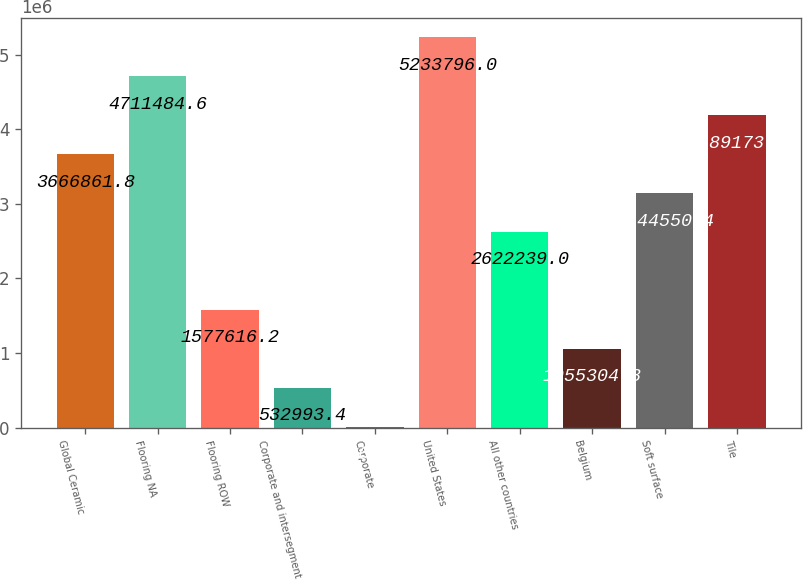Convert chart. <chart><loc_0><loc_0><loc_500><loc_500><bar_chart><fcel>Global Ceramic<fcel>Flooring NA<fcel>Flooring ROW<fcel>Corporate and intersegment<fcel>Corporate<fcel>United States<fcel>All other countries<fcel>Belgium<fcel>Soft surface<fcel>Tile<nl><fcel>3.66686e+06<fcel>4.71148e+06<fcel>1.57762e+06<fcel>532993<fcel>10682<fcel>5.2338e+06<fcel>2.62224e+06<fcel>1.0553e+06<fcel>3.14455e+06<fcel>4.18917e+06<nl></chart> 